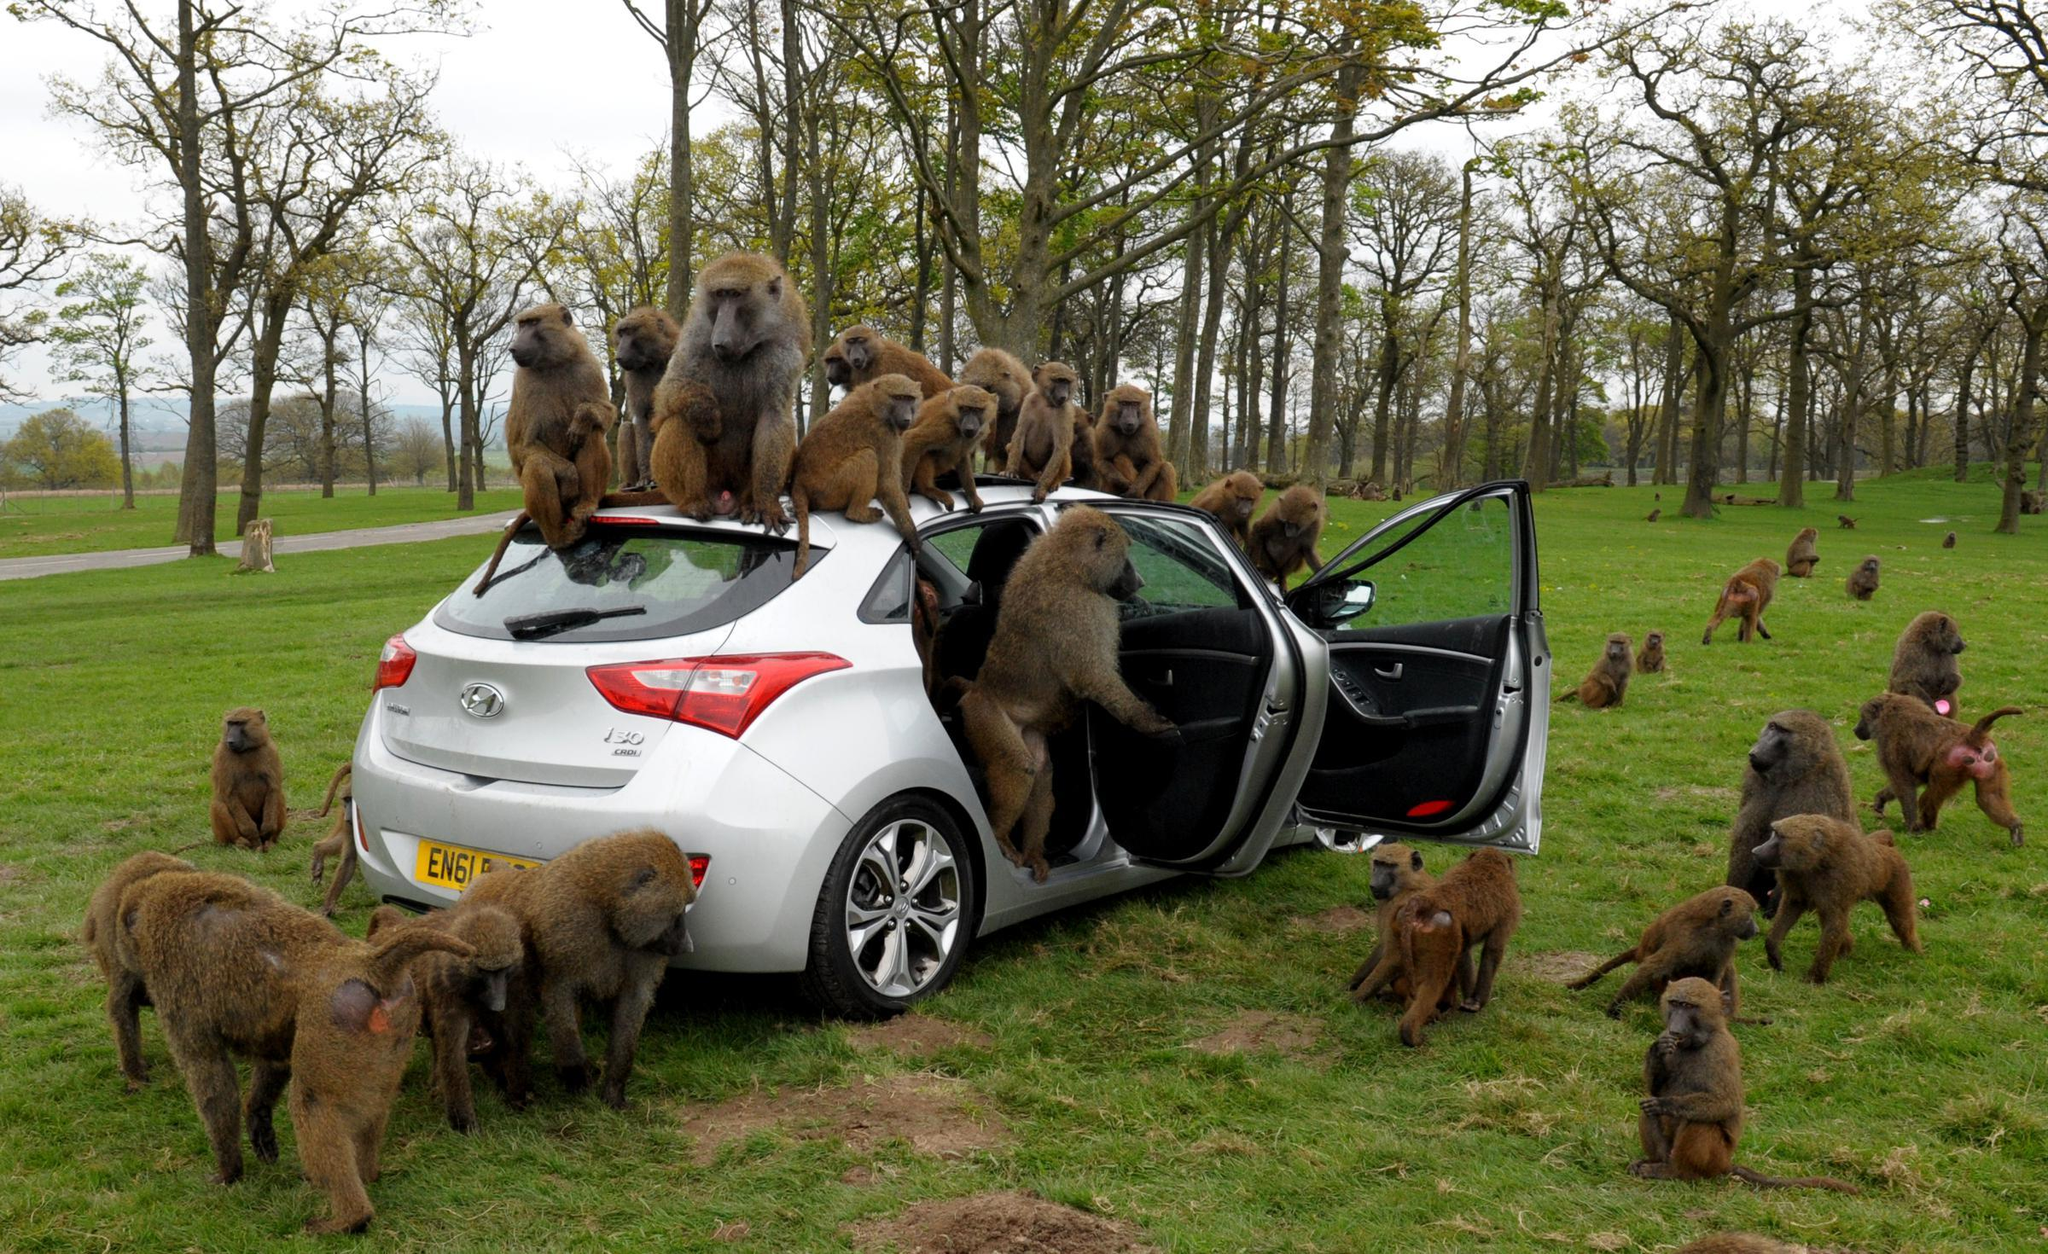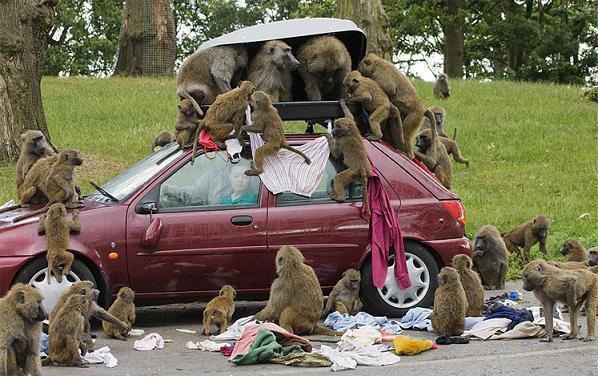The first image is the image on the left, the second image is the image on the right. Given the left and right images, does the statement "Several monkeys are sitting on top of a vehicle." hold true? Answer yes or no. Yes. The first image is the image on the left, the second image is the image on the right. For the images shown, is this caption "In one image monkeys are interacting with a white vehicle with the doors open." true? Answer yes or no. Yes. 